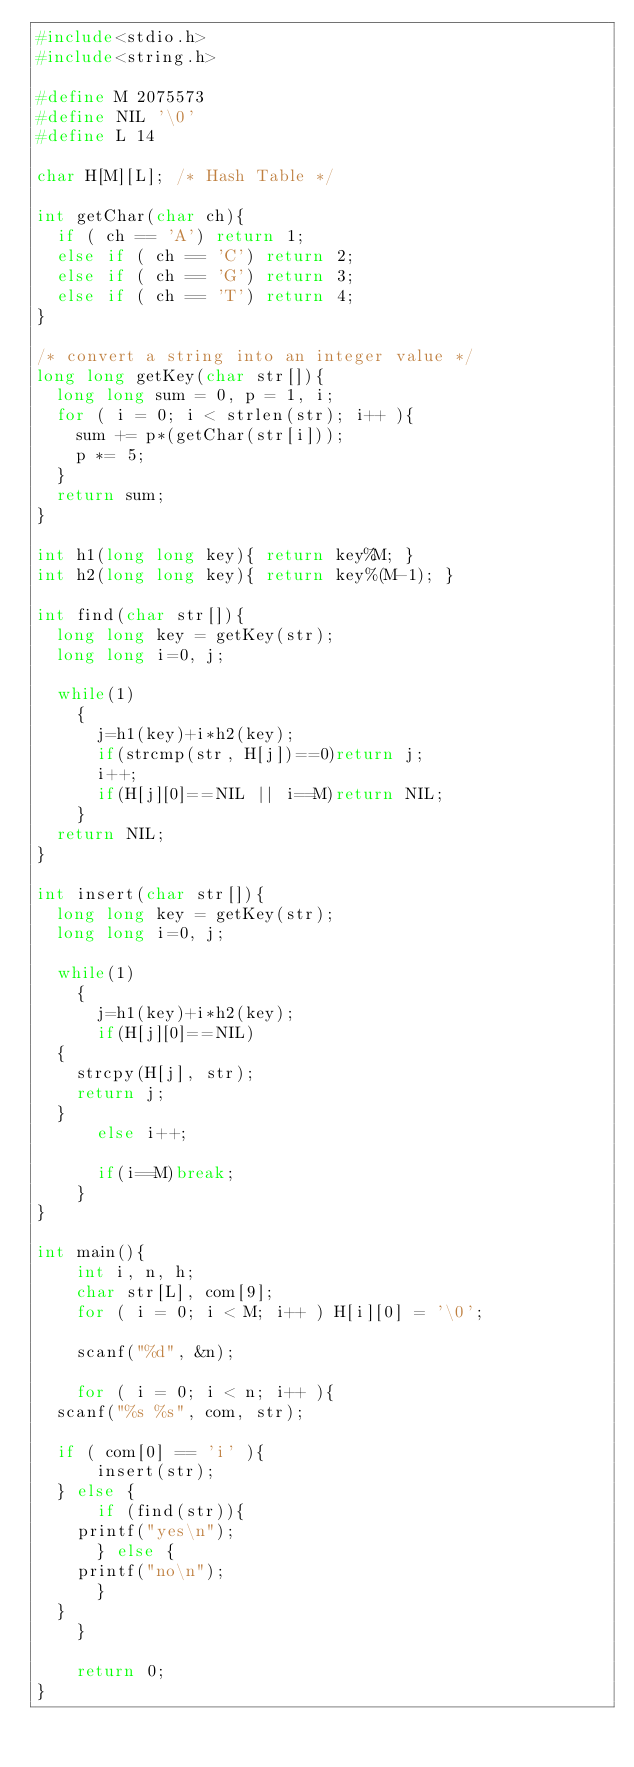Convert code to text. <code><loc_0><loc_0><loc_500><loc_500><_C_>#include<stdio.h>
#include<string.h>

#define M 2075573
#define NIL '\0'
#define L 14

char H[M][L]; /* Hash Table */

int getChar(char ch){
  if ( ch == 'A') return 1;
  else if ( ch == 'C') return 2;
  else if ( ch == 'G') return 3;
  else if ( ch == 'T') return 4;
}

/* convert a string into an integer value */
long long getKey(char str[]){
  long long sum = 0, p = 1, i;
  for ( i = 0; i < strlen(str); i++ ){
    sum += p*(getChar(str[i]));
    p *= 5;
  }
  return sum;
}

int h1(long long key){ return key%M; }
int h2(long long key){ return key%(M-1); }

int find(char str[]){
  long long key = getKey(str);
  long long i=0, j;

  while(1)
    {
      j=h1(key)+i*h2(key);
      if(strcmp(str, H[j])==0)return j;
      i++;
      if(H[j][0]==NIL || i==M)return NIL;
    }
  return NIL;
}

int insert(char str[]){
  long long key = getKey(str);
  long long i=0, j;

  while(1)
    {
      j=h1(key)+i*h2(key);
      if(H[j][0]==NIL)
	{
	  strcpy(H[j], str);
	  return j;
	}
      else i++;

      if(i==M)break;
    }
}

int main(){
    int i, n, h;
    char str[L], com[9];
    for ( i = 0; i < M; i++ ) H[i][0] = '\0';
    
    scanf("%d", &n);
    
    for ( i = 0; i < n; i++ ){
	scanf("%s %s", com, str);
	
	if ( com[0] == 'i' ){
	    insert(str);
	} else {
	    if (find(str)){
		printf("yes\n");
	    } else {
		printf("no\n");
	    }
	}
    }

    return 0;
}</code> 